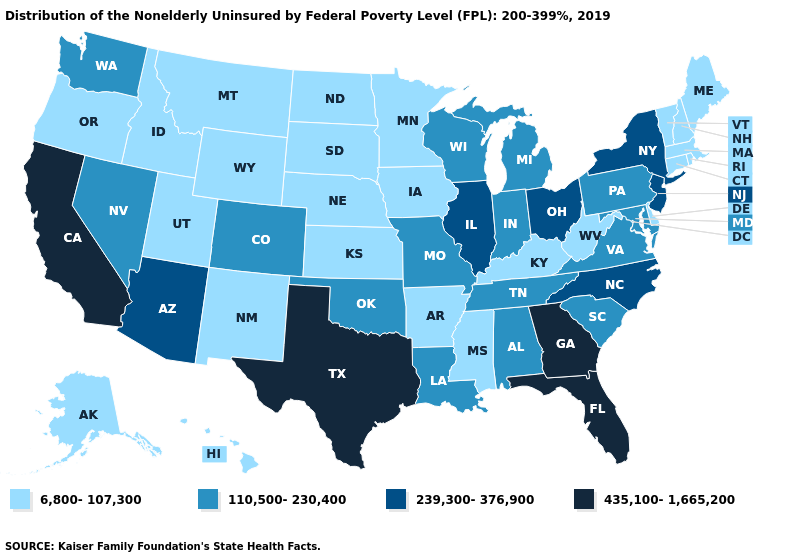Which states have the lowest value in the West?
Write a very short answer. Alaska, Hawaii, Idaho, Montana, New Mexico, Oregon, Utah, Wyoming. Does the map have missing data?
Answer briefly. No. What is the value of Illinois?
Give a very brief answer. 239,300-376,900. What is the value of Minnesota?
Give a very brief answer. 6,800-107,300. Name the states that have a value in the range 110,500-230,400?
Concise answer only. Alabama, Colorado, Indiana, Louisiana, Maryland, Michigan, Missouri, Nevada, Oklahoma, Pennsylvania, South Carolina, Tennessee, Virginia, Washington, Wisconsin. Among the states that border Washington , which have the lowest value?
Write a very short answer. Idaho, Oregon. What is the value of Tennessee?
Quick response, please. 110,500-230,400. Name the states that have a value in the range 6,800-107,300?
Quick response, please. Alaska, Arkansas, Connecticut, Delaware, Hawaii, Idaho, Iowa, Kansas, Kentucky, Maine, Massachusetts, Minnesota, Mississippi, Montana, Nebraska, New Hampshire, New Mexico, North Dakota, Oregon, Rhode Island, South Dakota, Utah, Vermont, West Virginia, Wyoming. Among the states that border Arkansas , which have the highest value?
Write a very short answer. Texas. Which states have the lowest value in the USA?
Short answer required. Alaska, Arkansas, Connecticut, Delaware, Hawaii, Idaho, Iowa, Kansas, Kentucky, Maine, Massachusetts, Minnesota, Mississippi, Montana, Nebraska, New Hampshire, New Mexico, North Dakota, Oregon, Rhode Island, South Dakota, Utah, Vermont, West Virginia, Wyoming. What is the value of New Mexico?
Quick response, please. 6,800-107,300. Which states have the lowest value in the South?
Concise answer only. Arkansas, Delaware, Kentucky, Mississippi, West Virginia. Which states have the lowest value in the West?
Concise answer only. Alaska, Hawaii, Idaho, Montana, New Mexico, Oregon, Utah, Wyoming. Name the states that have a value in the range 435,100-1,665,200?
Short answer required. California, Florida, Georgia, Texas. Name the states that have a value in the range 110,500-230,400?
Quick response, please. Alabama, Colorado, Indiana, Louisiana, Maryland, Michigan, Missouri, Nevada, Oklahoma, Pennsylvania, South Carolina, Tennessee, Virginia, Washington, Wisconsin. 